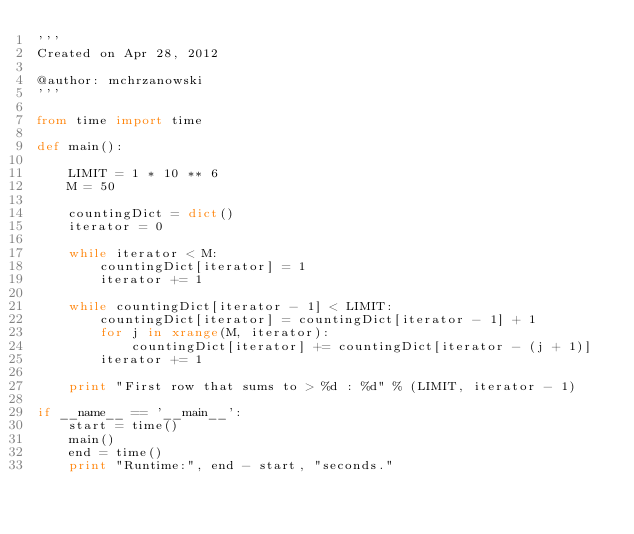<code> <loc_0><loc_0><loc_500><loc_500><_Python_>'''
Created on Apr 28, 2012

@author: mchrzanowski
'''

from time import time

def main():
    
    LIMIT = 1 * 10 ** 6
    M = 50
    
    countingDict = dict()
    iterator = 0
    
    while iterator < M: 
        countingDict[iterator] = 1
        iterator += 1
        
    while countingDict[iterator - 1] < LIMIT:
        countingDict[iterator] = countingDict[iterator - 1] + 1
        for j in xrange(M, iterator):
            countingDict[iterator] += countingDict[iterator - (j + 1)]
        iterator += 1
    
    print "First row that sums to > %d : %d" % (LIMIT, iterator - 1)

if __name__ == '__main__':
    start = time()
    main()
    end = time()
    print "Runtime:", end - start, "seconds."</code> 